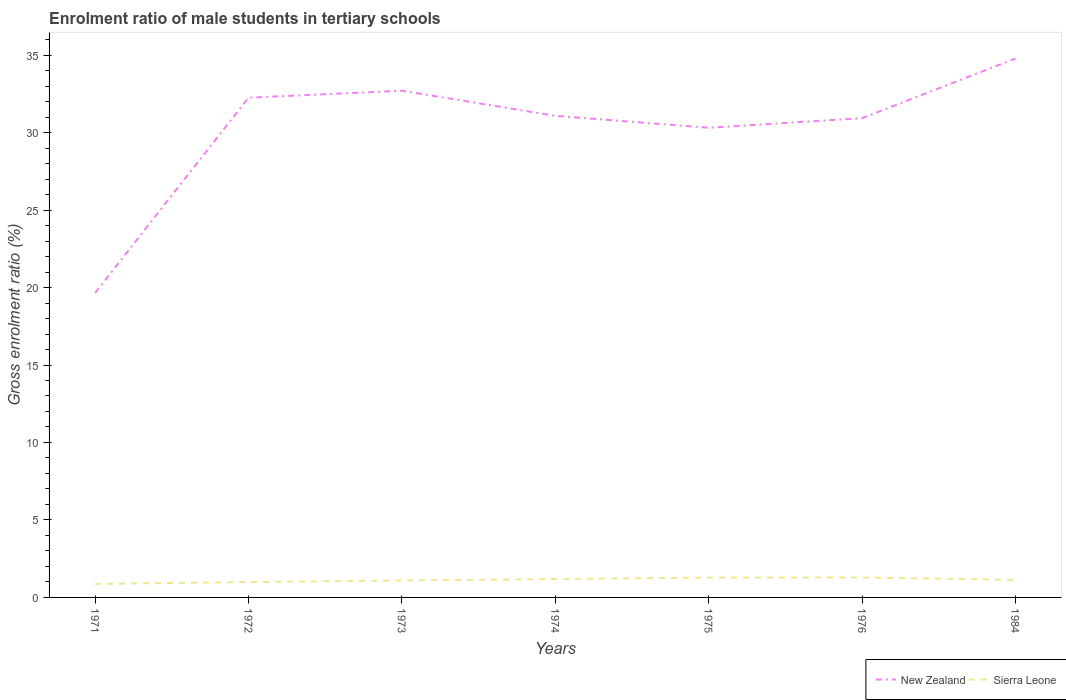Across all years, what is the maximum enrolment ratio of male students in tertiary schools in New Zealand?
Keep it short and to the point. 19.65. What is the total enrolment ratio of male students in tertiary schools in Sierra Leone in the graph?
Make the answer very short. -0.12. What is the difference between the highest and the second highest enrolment ratio of male students in tertiary schools in New Zealand?
Offer a very short reply. 15.13. How many lines are there?
Your answer should be compact. 2. Does the graph contain grids?
Give a very brief answer. No. How many legend labels are there?
Provide a short and direct response. 2. What is the title of the graph?
Offer a very short reply. Enrolment ratio of male students in tertiary schools. What is the label or title of the X-axis?
Keep it short and to the point. Years. What is the Gross enrolment ratio (%) in New Zealand in 1971?
Your answer should be very brief. 19.65. What is the Gross enrolment ratio (%) in Sierra Leone in 1971?
Ensure brevity in your answer.  0.87. What is the Gross enrolment ratio (%) of New Zealand in 1972?
Provide a succinct answer. 32.25. What is the Gross enrolment ratio (%) in Sierra Leone in 1972?
Ensure brevity in your answer.  0.99. What is the Gross enrolment ratio (%) of New Zealand in 1973?
Your answer should be very brief. 32.7. What is the Gross enrolment ratio (%) in Sierra Leone in 1973?
Ensure brevity in your answer.  1.09. What is the Gross enrolment ratio (%) of New Zealand in 1974?
Ensure brevity in your answer.  31.08. What is the Gross enrolment ratio (%) in Sierra Leone in 1974?
Provide a succinct answer. 1.18. What is the Gross enrolment ratio (%) of New Zealand in 1975?
Provide a succinct answer. 30.31. What is the Gross enrolment ratio (%) of Sierra Leone in 1975?
Provide a short and direct response. 1.28. What is the Gross enrolment ratio (%) of New Zealand in 1976?
Ensure brevity in your answer.  30.93. What is the Gross enrolment ratio (%) of Sierra Leone in 1976?
Provide a succinct answer. 1.29. What is the Gross enrolment ratio (%) of New Zealand in 1984?
Give a very brief answer. 34.78. What is the Gross enrolment ratio (%) of Sierra Leone in 1984?
Give a very brief answer. 1.13. Across all years, what is the maximum Gross enrolment ratio (%) in New Zealand?
Provide a succinct answer. 34.78. Across all years, what is the maximum Gross enrolment ratio (%) of Sierra Leone?
Give a very brief answer. 1.29. Across all years, what is the minimum Gross enrolment ratio (%) in New Zealand?
Offer a very short reply. 19.65. Across all years, what is the minimum Gross enrolment ratio (%) in Sierra Leone?
Offer a terse response. 0.87. What is the total Gross enrolment ratio (%) of New Zealand in the graph?
Your response must be concise. 211.71. What is the total Gross enrolment ratio (%) in Sierra Leone in the graph?
Provide a succinct answer. 7.85. What is the difference between the Gross enrolment ratio (%) of New Zealand in 1971 and that in 1972?
Your response must be concise. -12.6. What is the difference between the Gross enrolment ratio (%) in Sierra Leone in 1971 and that in 1972?
Your answer should be very brief. -0.12. What is the difference between the Gross enrolment ratio (%) of New Zealand in 1971 and that in 1973?
Keep it short and to the point. -13.05. What is the difference between the Gross enrolment ratio (%) of Sierra Leone in 1971 and that in 1973?
Your response must be concise. -0.22. What is the difference between the Gross enrolment ratio (%) of New Zealand in 1971 and that in 1974?
Your answer should be compact. -11.43. What is the difference between the Gross enrolment ratio (%) in Sierra Leone in 1971 and that in 1974?
Make the answer very short. -0.31. What is the difference between the Gross enrolment ratio (%) in New Zealand in 1971 and that in 1975?
Provide a short and direct response. -10.66. What is the difference between the Gross enrolment ratio (%) in Sierra Leone in 1971 and that in 1975?
Provide a succinct answer. -0.41. What is the difference between the Gross enrolment ratio (%) of New Zealand in 1971 and that in 1976?
Offer a very short reply. -11.28. What is the difference between the Gross enrolment ratio (%) of Sierra Leone in 1971 and that in 1976?
Offer a very short reply. -0.42. What is the difference between the Gross enrolment ratio (%) of New Zealand in 1971 and that in 1984?
Ensure brevity in your answer.  -15.13. What is the difference between the Gross enrolment ratio (%) of Sierra Leone in 1971 and that in 1984?
Offer a very short reply. -0.26. What is the difference between the Gross enrolment ratio (%) of New Zealand in 1972 and that in 1973?
Give a very brief answer. -0.45. What is the difference between the Gross enrolment ratio (%) in Sierra Leone in 1972 and that in 1973?
Your answer should be very brief. -0.1. What is the difference between the Gross enrolment ratio (%) in New Zealand in 1972 and that in 1974?
Ensure brevity in your answer.  1.17. What is the difference between the Gross enrolment ratio (%) of Sierra Leone in 1972 and that in 1974?
Offer a terse response. -0.19. What is the difference between the Gross enrolment ratio (%) in New Zealand in 1972 and that in 1975?
Keep it short and to the point. 1.94. What is the difference between the Gross enrolment ratio (%) in Sierra Leone in 1972 and that in 1975?
Offer a terse response. -0.29. What is the difference between the Gross enrolment ratio (%) in New Zealand in 1972 and that in 1976?
Provide a succinct answer. 1.32. What is the difference between the Gross enrolment ratio (%) of Sierra Leone in 1972 and that in 1976?
Offer a very short reply. -0.29. What is the difference between the Gross enrolment ratio (%) of New Zealand in 1972 and that in 1984?
Provide a short and direct response. -2.53. What is the difference between the Gross enrolment ratio (%) of Sierra Leone in 1972 and that in 1984?
Ensure brevity in your answer.  -0.14. What is the difference between the Gross enrolment ratio (%) in New Zealand in 1973 and that in 1974?
Provide a short and direct response. 1.62. What is the difference between the Gross enrolment ratio (%) in Sierra Leone in 1973 and that in 1974?
Offer a very short reply. -0.09. What is the difference between the Gross enrolment ratio (%) of New Zealand in 1973 and that in 1975?
Offer a very short reply. 2.39. What is the difference between the Gross enrolment ratio (%) in Sierra Leone in 1973 and that in 1975?
Offer a terse response. -0.19. What is the difference between the Gross enrolment ratio (%) of New Zealand in 1973 and that in 1976?
Give a very brief answer. 1.77. What is the difference between the Gross enrolment ratio (%) of Sierra Leone in 1973 and that in 1976?
Make the answer very short. -0.19. What is the difference between the Gross enrolment ratio (%) of New Zealand in 1973 and that in 1984?
Give a very brief answer. -2.08. What is the difference between the Gross enrolment ratio (%) of Sierra Leone in 1973 and that in 1984?
Make the answer very short. -0.04. What is the difference between the Gross enrolment ratio (%) of New Zealand in 1974 and that in 1975?
Your answer should be compact. 0.77. What is the difference between the Gross enrolment ratio (%) of Sierra Leone in 1974 and that in 1975?
Your answer should be very brief. -0.1. What is the difference between the Gross enrolment ratio (%) of New Zealand in 1974 and that in 1976?
Provide a short and direct response. 0.15. What is the difference between the Gross enrolment ratio (%) in Sierra Leone in 1974 and that in 1976?
Keep it short and to the point. -0.1. What is the difference between the Gross enrolment ratio (%) of New Zealand in 1974 and that in 1984?
Your response must be concise. -3.7. What is the difference between the Gross enrolment ratio (%) of Sierra Leone in 1974 and that in 1984?
Your answer should be compact. 0.05. What is the difference between the Gross enrolment ratio (%) in New Zealand in 1975 and that in 1976?
Provide a succinct answer. -0.62. What is the difference between the Gross enrolment ratio (%) in Sierra Leone in 1975 and that in 1976?
Ensure brevity in your answer.  -0. What is the difference between the Gross enrolment ratio (%) in New Zealand in 1975 and that in 1984?
Your answer should be very brief. -4.47. What is the difference between the Gross enrolment ratio (%) in Sierra Leone in 1975 and that in 1984?
Offer a very short reply. 0.15. What is the difference between the Gross enrolment ratio (%) of New Zealand in 1976 and that in 1984?
Your answer should be very brief. -3.85. What is the difference between the Gross enrolment ratio (%) of Sierra Leone in 1976 and that in 1984?
Ensure brevity in your answer.  0.15. What is the difference between the Gross enrolment ratio (%) of New Zealand in 1971 and the Gross enrolment ratio (%) of Sierra Leone in 1972?
Give a very brief answer. 18.66. What is the difference between the Gross enrolment ratio (%) of New Zealand in 1971 and the Gross enrolment ratio (%) of Sierra Leone in 1973?
Keep it short and to the point. 18.56. What is the difference between the Gross enrolment ratio (%) of New Zealand in 1971 and the Gross enrolment ratio (%) of Sierra Leone in 1974?
Your answer should be very brief. 18.47. What is the difference between the Gross enrolment ratio (%) of New Zealand in 1971 and the Gross enrolment ratio (%) of Sierra Leone in 1975?
Offer a terse response. 18.37. What is the difference between the Gross enrolment ratio (%) of New Zealand in 1971 and the Gross enrolment ratio (%) of Sierra Leone in 1976?
Your response must be concise. 18.37. What is the difference between the Gross enrolment ratio (%) of New Zealand in 1971 and the Gross enrolment ratio (%) of Sierra Leone in 1984?
Give a very brief answer. 18.52. What is the difference between the Gross enrolment ratio (%) of New Zealand in 1972 and the Gross enrolment ratio (%) of Sierra Leone in 1973?
Your response must be concise. 31.16. What is the difference between the Gross enrolment ratio (%) of New Zealand in 1972 and the Gross enrolment ratio (%) of Sierra Leone in 1974?
Offer a very short reply. 31.07. What is the difference between the Gross enrolment ratio (%) of New Zealand in 1972 and the Gross enrolment ratio (%) of Sierra Leone in 1975?
Keep it short and to the point. 30.97. What is the difference between the Gross enrolment ratio (%) in New Zealand in 1972 and the Gross enrolment ratio (%) in Sierra Leone in 1976?
Keep it short and to the point. 30.96. What is the difference between the Gross enrolment ratio (%) in New Zealand in 1972 and the Gross enrolment ratio (%) in Sierra Leone in 1984?
Provide a short and direct response. 31.12. What is the difference between the Gross enrolment ratio (%) of New Zealand in 1973 and the Gross enrolment ratio (%) of Sierra Leone in 1974?
Keep it short and to the point. 31.52. What is the difference between the Gross enrolment ratio (%) in New Zealand in 1973 and the Gross enrolment ratio (%) in Sierra Leone in 1975?
Keep it short and to the point. 31.42. What is the difference between the Gross enrolment ratio (%) in New Zealand in 1973 and the Gross enrolment ratio (%) in Sierra Leone in 1976?
Keep it short and to the point. 31.41. What is the difference between the Gross enrolment ratio (%) of New Zealand in 1973 and the Gross enrolment ratio (%) of Sierra Leone in 1984?
Your response must be concise. 31.57. What is the difference between the Gross enrolment ratio (%) in New Zealand in 1974 and the Gross enrolment ratio (%) in Sierra Leone in 1975?
Make the answer very short. 29.8. What is the difference between the Gross enrolment ratio (%) in New Zealand in 1974 and the Gross enrolment ratio (%) in Sierra Leone in 1976?
Ensure brevity in your answer.  29.79. What is the difference between the Gross enrolment ratio (%) of New Zealand in 1974 and the Gross enrolment ratio (%) of Sierra Leone in 1984?
Give a very brief answer. 29.95. What is the difference between the Gross enrolment ratio (%) in New Zealand in 1975 and the Gross enrolment ratio (%) in Sierra Leone in 1976?
Provide a short and direct response. 29.02. What is the difference between the Gross enrolment ratio (%) of New Zealand in 1975 and the Gross enrolment ratio (%) of Sierra Leone in 1984?
Give a very brief answer. 29.18. What is the difference between the Gross enrolment ratio (%) in New Zealand in 1976 and the Gross enrolment ratio (%) in Sierra Leone in 1984?
Give a very brief answer. 29.8. What is the average Gross enrolment ratio (%) of New Zealand per year?
Offer a terse response. 30.24. What is the average Gross enrolment ratio (%) of Sierra Leone per year?
Ensure brevity in your answer.  1.12. In the year 1971, what is the difference between the Gross enrolment ratio (%) in New Zealand and Gross enrolment ratio (%) in Sierra Leone?
Offer a terse response. 18.78. In the year 1972, what is the difference between the Gross enrolment ratio (%) of New Zealand and Gross enrolment ratio (%) of Sierra Leone?
Your response must be concise. 31.26. In the year 1973, what is the difference between the Gross enrolment ratio (%) of New Zealand and Gross enrolment ratio (%) of Sierra Leone?
Your answer should be compact. 31.61. In the year 1974, what is the difference between the Gross enrolment ratio (%) of New Zealand and Gross enrolment ratio (%) of Sierra Leone?
Give a very brief answer. 29.9. In the year 1975, what is the difference between the Gross enrolment ratio (%) of New Zealand and Gross enrolment ratio (%) of Sierra Leone?
Make the answer very short. 29.03. In the year 1976, what is the difference between the Gross enrolment ratio (%) in New Zealand and Gross enrolment ratio (%) in Sierra Leone?
Your response must be concise. 29.65. In the year 1984, what is the difference between the Gross enrolment ratio (%) of New Zealand and Gross enrolment ratio (%) of Sierra Leone?
Offer a very short reply. 33.65. What is the ratio of the Gross enrolment ratio (%) of New Zealand in 1971 to that in 1972?
Keep it short and to the point. 0.61. What is the ratio of the Gross enrolment ratio (%) of Sierra Leone in 1971 to that in 1972?
Ensure brevity in your answer.  0.88. What is the ratio of the Gross enrolment ratio (%) of New Zealand in 1971 to that in 1973?
Offer a terse response. 0.6. What is the ratio of the Gross enrolment ratio (%) in Sierra Leone in 1971 to that in 1973?
Provide a short and direct response. 0.8. What is the ratio of the Gross enrolment ratio (%) of New Zealand in 1971 to that in 1974?
Your response must be concise. 0.63. What is the ratio of the Gross enrolment ratio (%) in Sierra Leone in 1971 to that in 1974?
Give a very brief answer. 0.74. What is the ratio of the Gross enrolment ratio (%) of New Zealand in 1971 to that in 1975?
Offer a very short reply. 0.65. What is the ratio of the Gross enrolment ratio (%) of Sierra Leone in 1971 to that in 1975?
Give a very brief answer. 0.68. What is the ratio of the Gross enrolment ratio (%) of New Zealand in 1971 to that in 1976?
Your answer should be compact. 0.64. What is the ratio of the Gross enrolment ratio (%) of Sierra Leone in 1971 to that in 1976?
Keep it short and to the point. 0.68. What is the ratio of the Gross enrolment ratio (%) in New Zealand in 1971 to that in 1984?
Your answer should be very brief. 0.57. What is the ratio of the Gross enrolment ratio (%) of Sierra Leone in 1971 to that in 1984?
Ensure brevity in your answer.  0.77. What is the ratio of the Gross enrolment ratio (%) of New Zealand in 1972 to that in 1973?
Provide a succinct answer. 0.99. What is the ratio of the Gross enrolment ratio (%) of Sierra Leone in 1972 to that in 1973?
Your response must be concise. 0.91. What is the ratio of the Gross enrolment ratio (%) of New Zealand in 1972 to that in 1974?
Make the answer very short. 1.04. What is the ratio of the Gross enrolment ratio (%) in Sierra Leone in 1972 to that in 1974?
Provide a succinct answer. 0.84. What is the ratio of the Gross enrolment ratio (%) of New Zealand in 1972 to that in 1975?
Your response must be concise. 1.06. What is the ratio of the Gross enrolment ratio (%) of Sierra Leone in 1972 to that in 1975?
Provide a succinct answer. 0.77. What is the ratio of the Gross enrolment ratio (%) of New Zealand in 1972 to that in 1976?
Offer a terse response. 1.04. What is the ratio of the Gross enrolment ratio (%) of Sierra Leone in 1972 to that in 1976?
Provide a succinct answer. 0.77. What is the ratio of the Gross enrolment ratio (%) in New Zealand in 1972 to that in 1984?
Ensure brevity in your answer.  0.93. What is the ratio of the Gross enrolment ratio (%) in Sierra Leone in 1972 to that in 1984?
Your response must be concise. 0.88. What is the ratio of the Gross enrolment ratio (%) of New Zealand in 1973 to that in 1974?
Offer a terse response. 1.05. What is the ratio of the Gross enrolment ratio (%) in Sierra Leone in 1973 to that in 1974?
Make the answer very short. 0.92. What is the ratio of the Gross enrolment ratio (%) of New Zealand in 1973 to that in 1975?
Your answer should be compact. 1.08. What is the ratio of the Gross enrolment ratio (%) of Sierra Leone in 1973 to that in 1975?
Your answer should be compact. 0.85. What is the ratio of the Gross enrolment ratio (%) in New Zealand in 1973 to that in 1976?
Provide a short and direct response. 1.06. What is the ratio of the Gross enrolment ratio (%) of Sierra Leone in 1973 to that in 1976?
Offer a very short reply. 0.85. What is the ratio of the Gross enrolment ratio (%) of New Zealand in 1973 to that in 1984?
Your answer should be very brief. 0.94. What is the ratio of the Gross enrolment ratio (%) in Sierra Leone in 1973 to that in 1984?
Make the answer very short. 0.97. What is the ratio of the Gross enrolment ratio (%) of New Zealand in 1974 to that in 1975?
Your response must be concise. 1.03. What is the ratio of the Gross enrolment ratio (%) of Sierra Leone in 1974 to that in 1975?
Your response must be concise. 0.92. What is the ratio of the Gross enrolment ratio (%) in Sierra Leone in 1974 to that in 1976?
Offer a terse response. 0.92. What is the ratio of the Gross enrolment ratio (%) of New Zealand in 1974 to that in 1984?
Your answer should be very brief. 0.89. What is the ratio of the Gross enrolment ratio (%) in Sierra Leone in 1974 to that in 1984?
Your answer should be compact. 1.05. What is the ratio of the Gross enrolment ratio (%) of New Zealand in 1975 to that in 1976?
Your response must be concise. 0.98. What is the ratio of the Gross enrolment ratio (%) in New Zealand in 1975 to that in 1984?
Keep it short and to the point. 0.87. What is the ratio of the Gross enrolment ratio (%) of Sierra Leone in 1975 to that in 1984?
Provide a succinct answer. 1.13. What is the ratio of the Gross enrolment ratio (%) of New Zealand in 1976 to that in 1984?
Offer a very short reply. 0.89. What is the ratio of the Gross enrolment ratio (%) in Sierra Leone in 1976 to that in 1984?
Your answer should be very brief. 1.13. What is the difference between the highest and the second highest Gross enrolment ratio (%) of New Zealand?
Make the answer very short. 2.08. What is the difference between the highest and the second highest Gross enrolment ratio (%) in Sierra Leone?
Make the answer very short. 0. What is the difference between the highest and the lowest Gross enrolment ratio (%) of New Zealand?
Your answer should be very brief. 15.13. What is the difference between the highest and the lowest Gross enrolment ratio (%) of Sierra Leone?
Offer a very short reply. 0.42. 